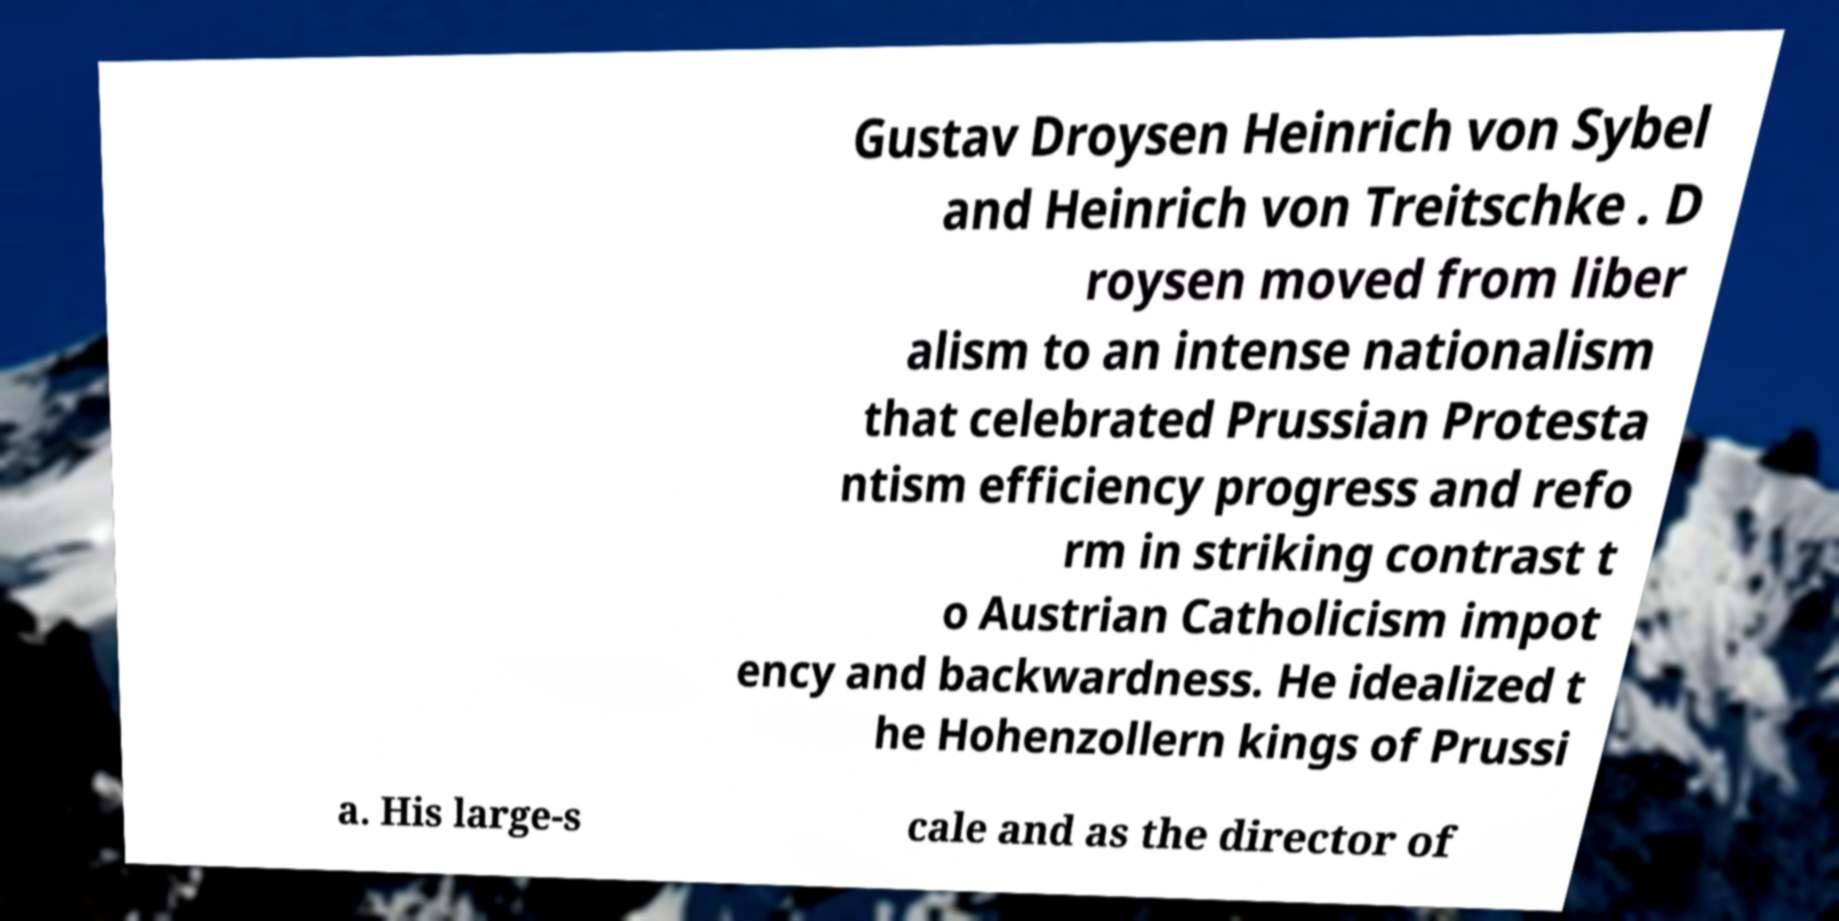What messages or text are displayed in this image? I need them in a readable, typed format. Gustav Droysen Heinrich von Sybel and Heinrich von Treitschke . D roysen moved from liber alism to an intense nationalism that celebrated Prussian Protesta ntism efficiency progress and refo rm in striking contrast t o Austrian Catholicism impot ency and backwardness. He idealized t he Hohenzollern kings of Prussi a. His large-s cale and as the director of 